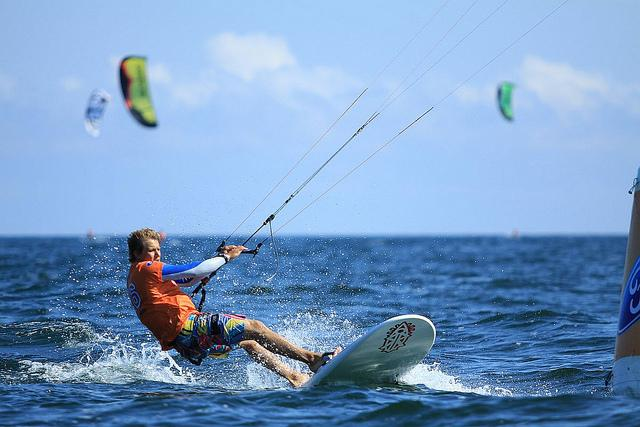The man who received the first patent for this sport was from which country?

Choices:
A) australia
B) togo
C) lithuania
D) netherlands netherlands 